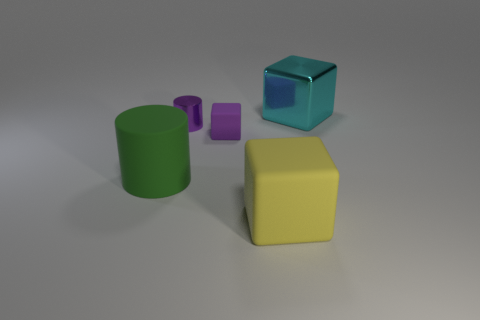Subtract all rubber cubes. How many cubes are left? 1 Add 4 tiny purple things. How many objects exist? 9 Subtract all cubes. How many objects are left? 2 Subtract 1 purple blocks. How many objects are left? 4 Subtract all cyan blocks. Subtract all tiny purple rubber objects. How many objects are left? 3 Add 3 large rubber cylinders. How many large rubber cylinders are left? 4 Add 1 tiny yellow balls. How many tiny yellow balls exist? 1 